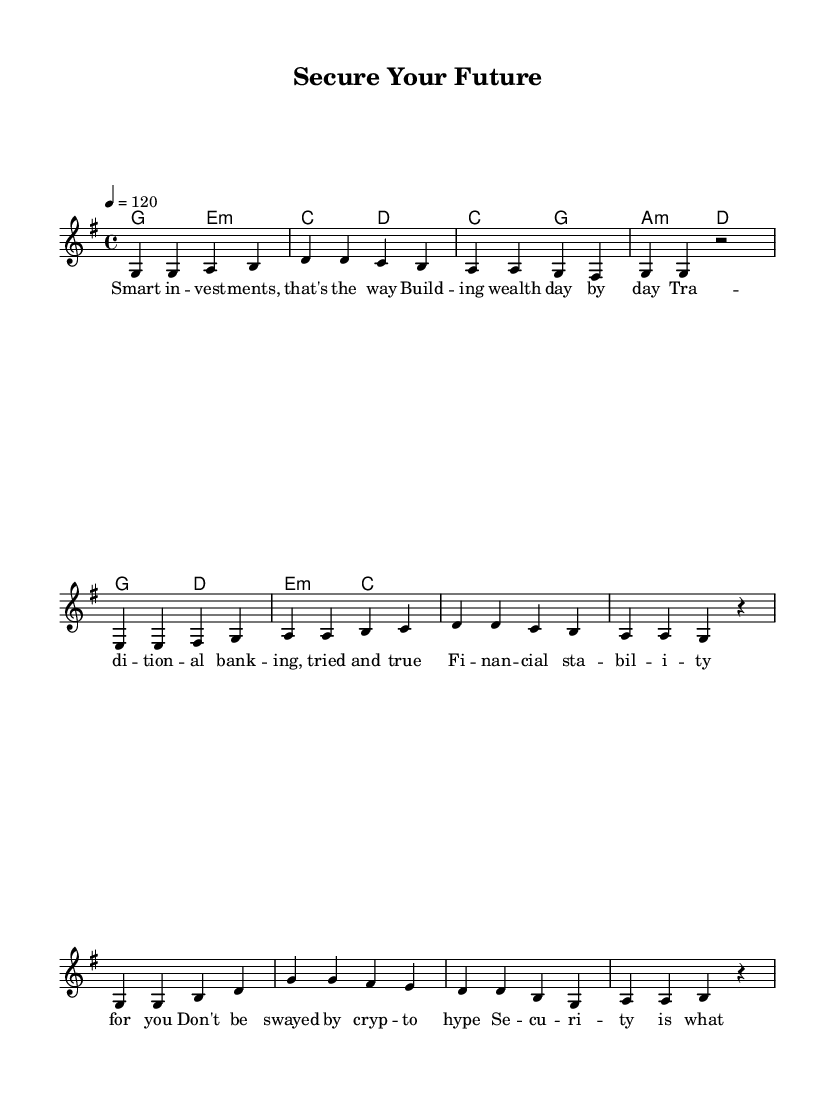What is the title of this piece? The title "Secure Your Future" is stated in the header section of the sheet music.
Answer: Secure Your Future What is the key signature of this music? The key signature is G major, which has one sharp (F#), as indicated by the initial key signature marking in the global setting.
Answer: G major What is the time signature of this piece? The time signature is 4/4, which allows four beats in each measure and is noted in the global section of the sheet music.
Answer: 4/4 What is the tempo marking given for the piece? The tempo marking states "4 = 120", indicating a tempo of 120 beats per minute for the quarter note, which is specified in the global section.
Answer: 120 How many measures are present in the verse section? The verse section consists of four measures, as indicated by the four distinct groupings of notes in the melody for that part.
Answer: 4 What type of lyrics are expressed in the pre-chorus? The lyrics in the pre-chorus emphasize security and caution regarding investments, which is indicated by the wording provided in the lyric mode section.
Answer: Security What is a repeated message in both the chorus and verse? Both the chorus and verse promote themes of financial stability and smart investments, and this is reflected in the lyrics of each section throughout the piece.
Answer: Financial stability 